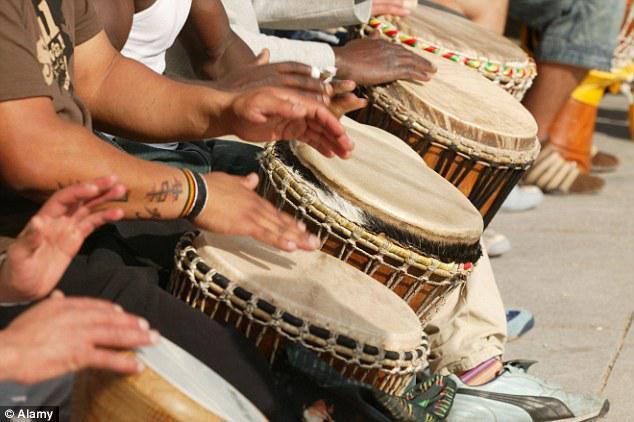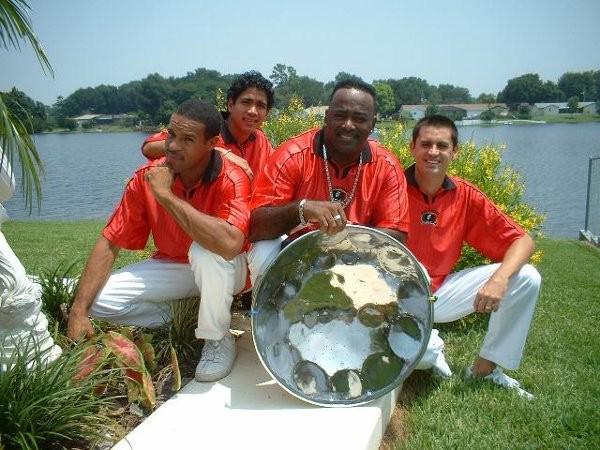The first image is the image on the left, the second image is the image on the right. For the images shown, is this caption "People are playing bongo drums." true? Answer yes or no. Yes. 